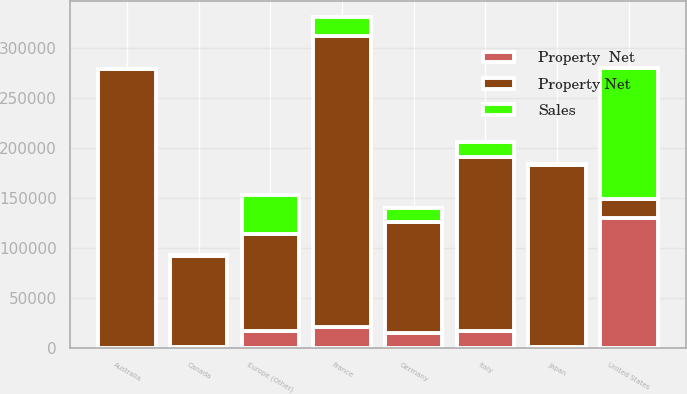Convert chart. <chart><loc_0><loc_0><loc_500><loc_500><stacked_bar_chart><ecel><fcel>United States<fcel>France<fcel>Australia<fcel>Japan<fcel>Italy<fcel>Germany<fcel>Europe (Other)<fcel>Canada<nl><fcel>Property Net<fcel>18776<fcel>290698<fcel>278298<fcel>182307<fcel>174095<fcel>110748<fcel>96381<fcel>90585<nl><fcel>Sales<fcel>131081<fcel>18776<fcel>320<fcel>942<fcel>15405<fcel>13649<fcel>38825<fcel>1093<nl><fcel>Property  Net<fcel>130235<fcel>20777<fcel>579<fcel>867<fcel>16785<fcel>15573<fcel>17242<fcel>1196<nl></chart> 